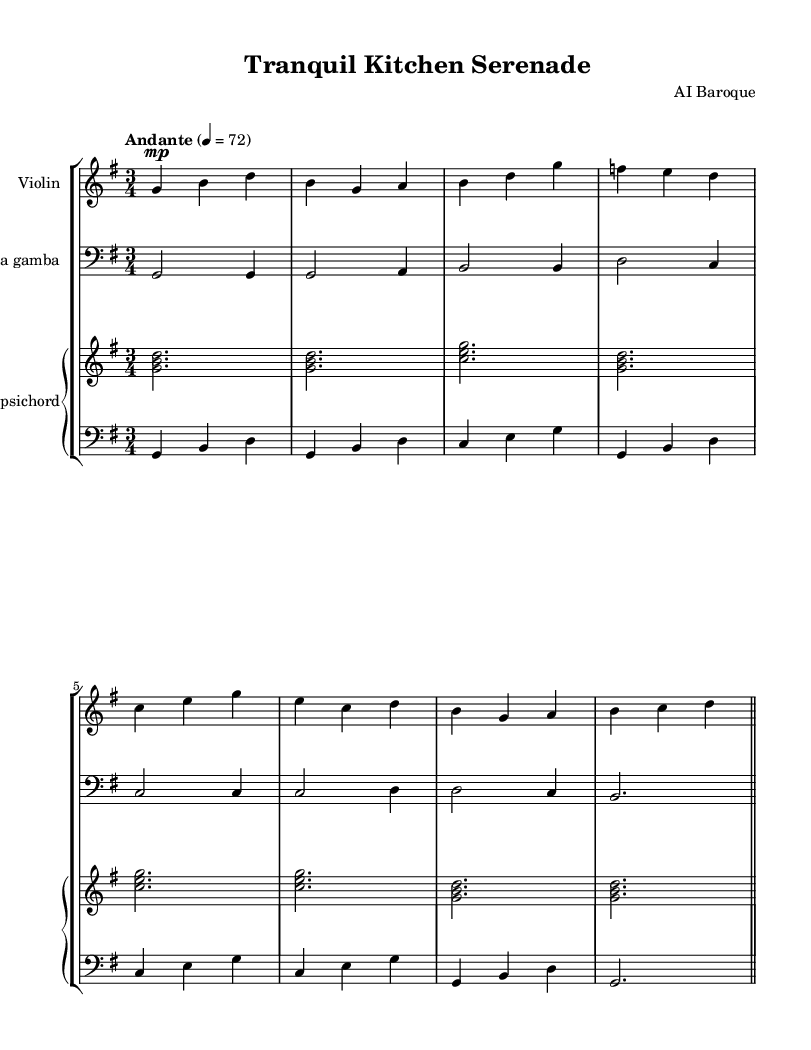What is the key signature of this music? The key signature is G major, indicated by one sharp (F#) at the beginning of the staff.
Answer: G major What is the time signature of this music? The time signature is 3/4, shown at the beginning of the music, indicating three beats per measure.
Answer: 3/4 What is the tempo marking of this piece? The tempo marking is "Andante," which indicates a moderately slow pace, usually around 76-108 beats per minute.
Answer: Andante How many instruments are used in this score? There are four instruments: Violin, Viola da gamba, and two parts for Harpsichord, combining to make a total of four staves.
Answer: Four Which instrument is playing the bass clef? The instrument playing the bass clef is the Viola da gamba and the left hand of the Harpsichord. This is indicated by the placement of the clef sign on their respective staves.
Answer: Viola da gamba What is the dynamic marking for the Violin part? The dynamic marking for the Violin part is "mp," meaning moderately soft, which indicates the volume at which the instrument should be played.
Answer: mp Which section of the score has chords written in it? The chords are written in the right hand of the Harpsichord part, represented by the stacked notes in the staff.
Answer: Harpsichord right 